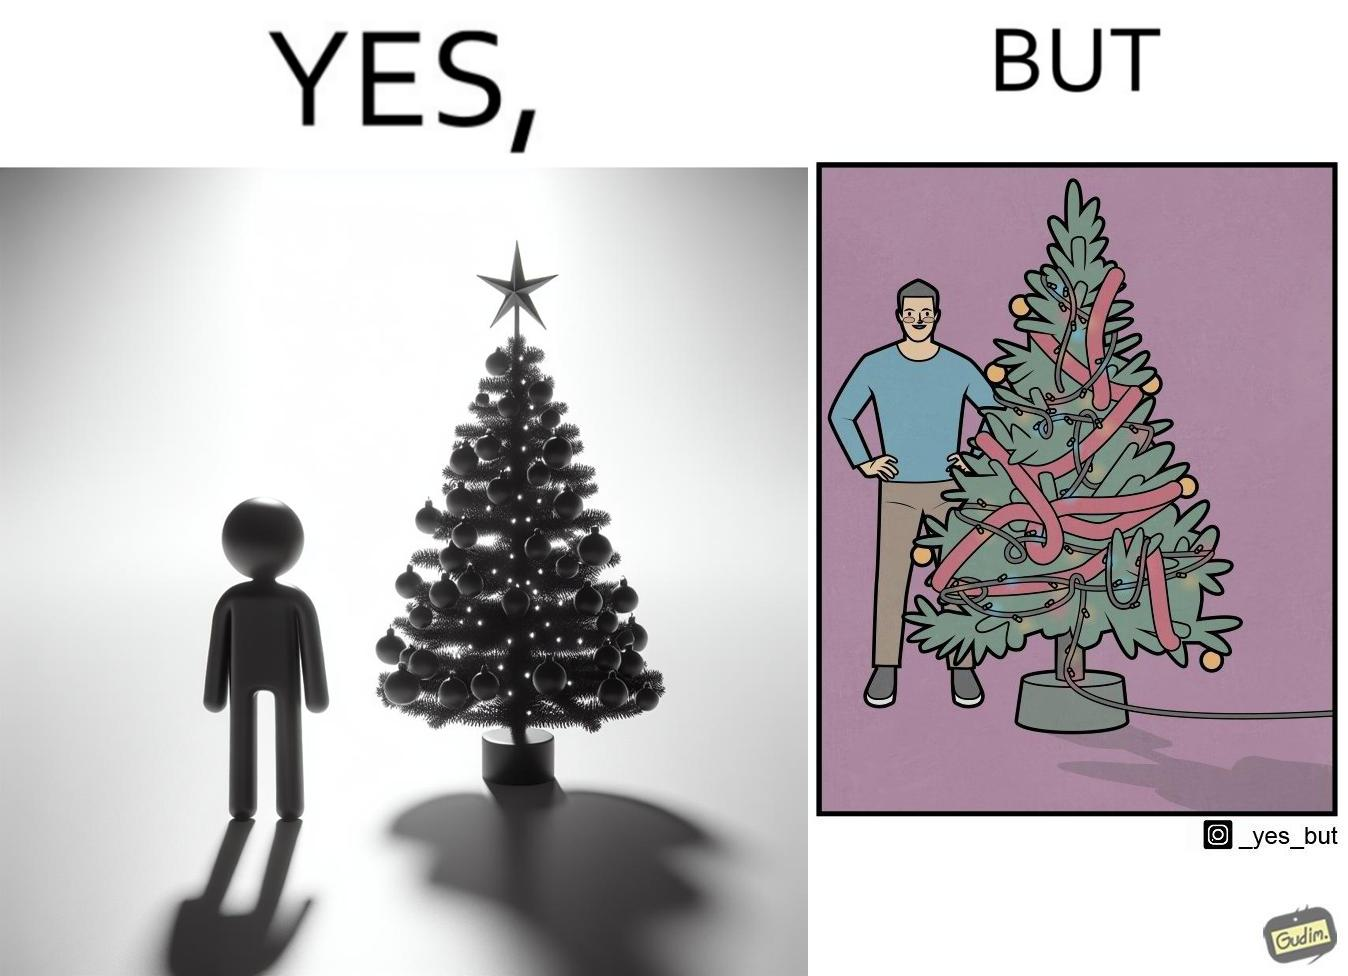Is this a satirical image? Yes, this image is satirical. 